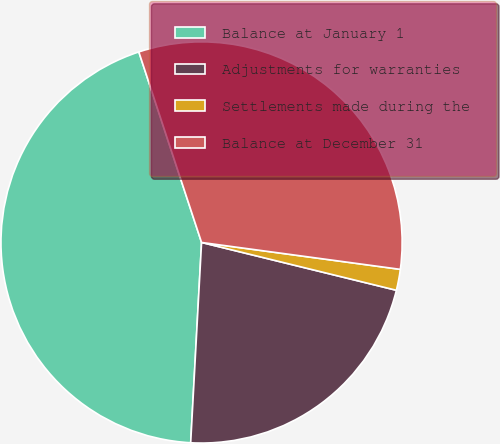Convert chart. <chart><loc_0><loc_0><loc_500><loc_500><pie_chart><fcel>Balance at January 1<fcel>Adjustments for warranties<fcel>Settlements made during the<fcel>Balance at December 31<nl><fcel>44.07%<fcel>22.03%<fcel>1.69%<fcel>32.2%<nl></chart> 